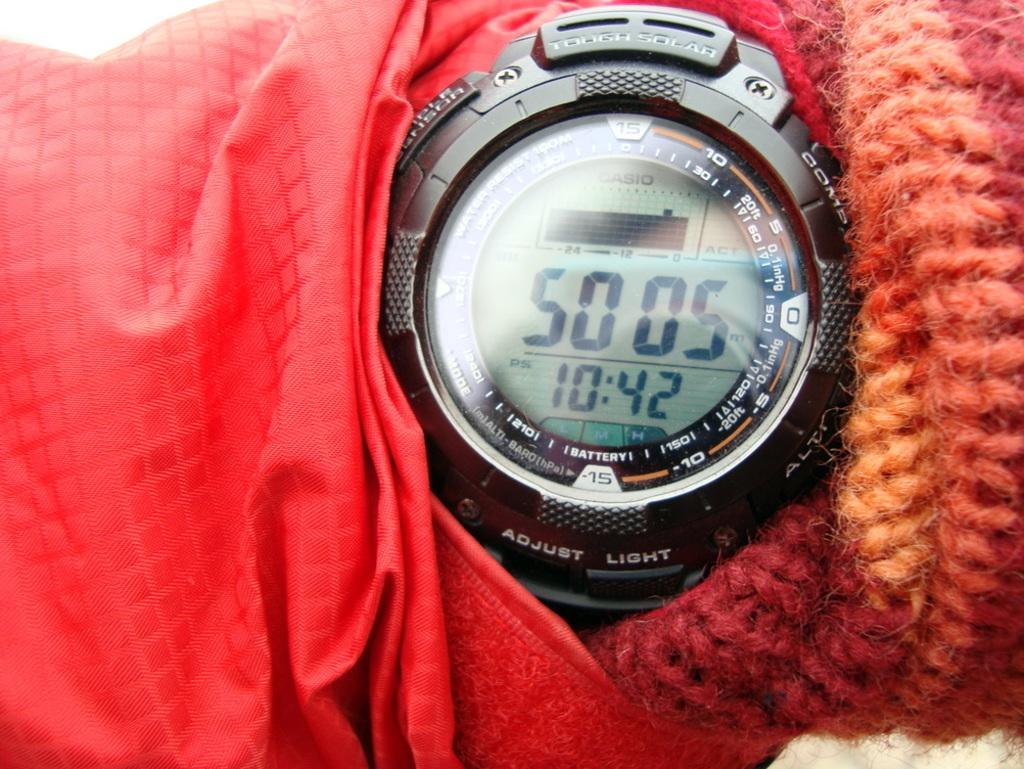Provide a one-sentence caption for the provided image. the persons black watch says 50 05 and 10:42. 